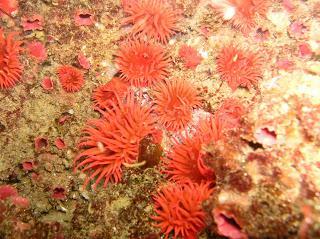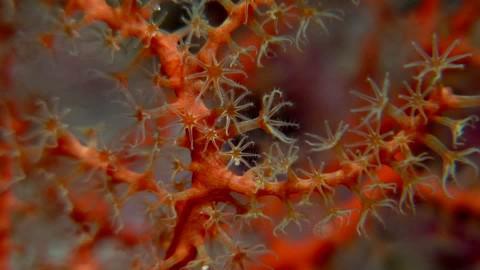The first image is the image on the left, the second image is the image on the right. Analyze the images presented: Is the assertion "An image shows multipe individual orange anemone and no other color anemone." valid? Answer yes or no. Yes. The first image is the image on the left, the second image is the image on the right. Examine the images to the left and right. Is the description "there are at least six red anemones in one of the images" accurate? Answer yes or no. Yes. 